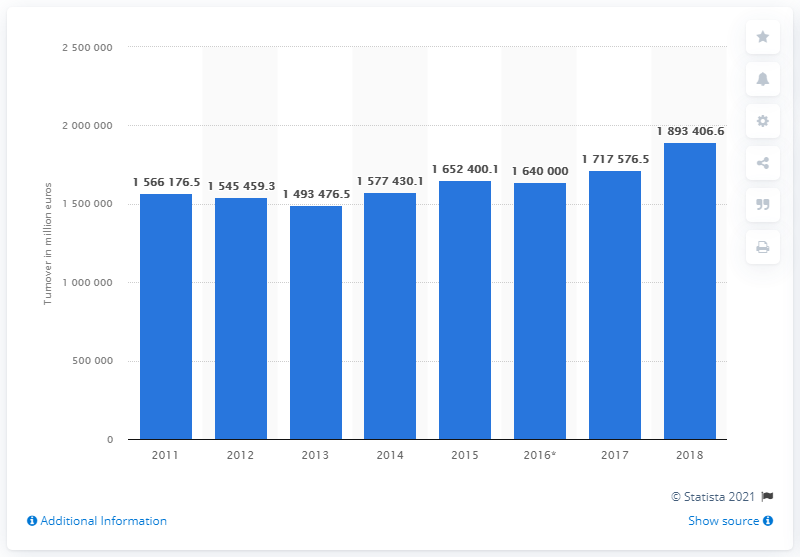Specify some key components in this picture. The estimated turnover of the construction industry in 2016 was approximately 164 million. In 2016, the turnover of the construction industry in the European Union was 189,340,606. 